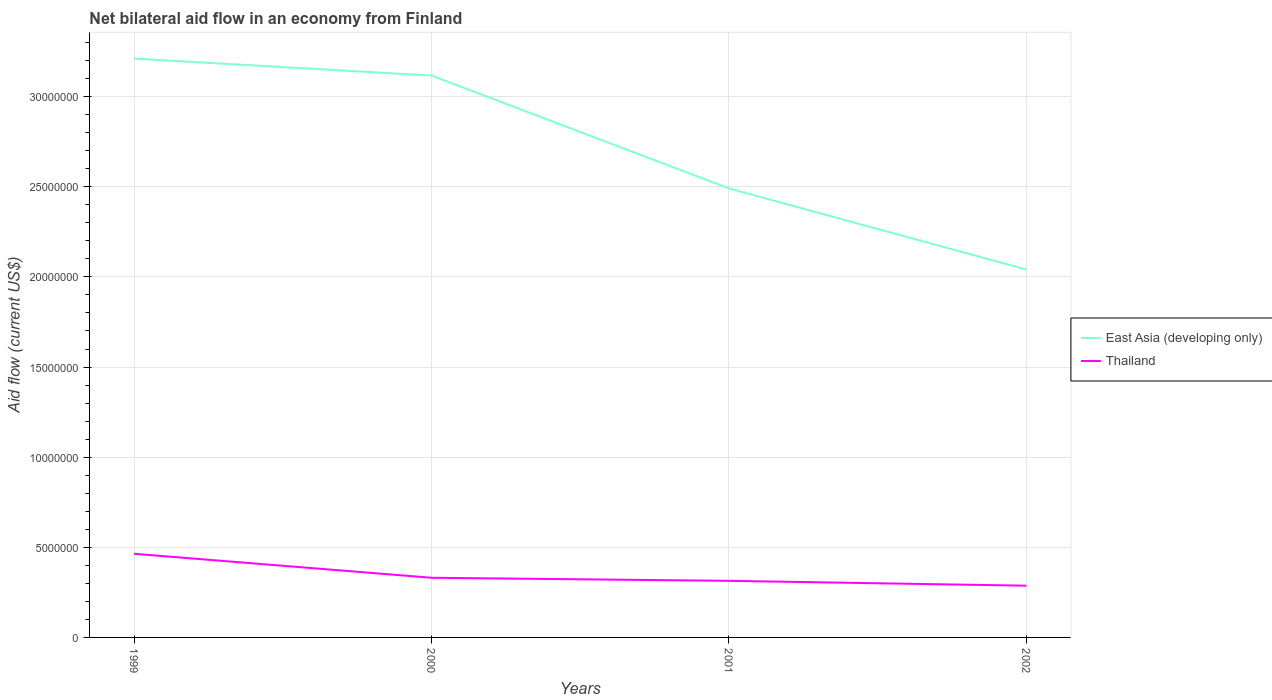How many different coloured lines are there?
Offer a terse response. 2. Across all years, what is the maximum net bilateral aid flow in Thailand?
Offer a very short reply. 2.87e+06. In which year was the net bilateral aid flow in East Asia (developing only) maximum?
Offer a terse response. 2002. What is the total net bilateral aid flow in Thailand in the graph?
Give a very brief answer. 4.40e+05. What is the difference between the highest and the second highest net bilateral aid flow in East Asia (developing only)?
Your response must be concise. 1.17e+07. What is the difference between the highest and the lowest net bilateral aid flow in East Asia (developing only)?
Offer a very short reply. 2. How many lines are there?
Provide a short and direct response. 2. Are the values on the major ticks of Y-axis written in scientific E-notation?
Provide a short and direct response. No. How many legend labels are there?
Provide a succinct answer. 2. What is the title of the graph?
Your response must be concise. Net bilateral aid flow in an economy from Finland. Does "St. Vincent and the Grenadines" appear as one of the legend labels in the graph?
Make the answer very short. No. What is the label or title of the Y-axis?
Provide a succinct answer. Aid flow (current US$). What is the Aid flow (current US$) of East Asia (developing only) in 1999?
Offer a very short reply. 3.21e+07. What is the Aid flow (current US$) in Thailand in 1999?
Offer a very short reply. 4.64e+06. What is the Aid flow (current US$) in East Asia (developing only) in 2000?
Your answer should be compact. 3.12e+07. What is the Aid flow (current US$) of Thailand in 2000?
Offer a terse response. 3.31e+06. What is the Aid flow (current US$) in East Asia (developing only) in 2001?
Provide a short and direct response. 2.49e+07. What is the Aid flow (current US$) of Thailand in 2001?
Provide a succinct answer. 3.14e+06. What is the Aid flow (current US$) in East Asia (developing only) in 2002?
Offer a terse response. 2.04e+07. What is the Aid flow (current US$) in Thailand in 2002?
Make the answer very short. 2.87e+06. Across all years, what is the maximum Aid flow (current US$) of East Asia (developing only)?
Give a very brief answer. 3.21e+07. Across all years, what is the maximum Aid flow (current US$) in Thailand?
Make the answer very short. 4.64e+06. Across all years, what is the minimum Aid flow (current US$) of East Asia (developing only)?
Provide a short and direct response. 2.04e+07. Across all years, what is the minimum Aid flow (current US$) of Thailand?
Provide a succinct answer. 2.87e+06. What is the total Aid flow (current US$) of East Asia (developing only) in the graph?
Offer a terse response. 1.09e+08. What is the total Aid flow (current US$) in Thailand in the graph?
Provide a short and direct response. 1.40e+07. What is the difference between the Aid flow (current US$) of East Asia (developing only) in 1999 and that in 2000?
Keep it short and to the point. 9.40e+05. What is the difference between the Aid flow (current US$) of Thailand in 1999 and that in 2000?
Make the answer very short. 1.33e+06. What is the difference between the Aid flow (current US$) in East Asia (developing only) in 1999 and that in 2001?
Offer a terse response. 7.20e+06. What is the difference between the Aid flow (current US$) in Thailand in 1999 and that in 2001?
Keep it short and to the point. 1.50e+06. What is the difference between the Aid flow (current US$) in East Asia (developing only) in 1999 and that in 2002?
Make the answer very short. 1.17e+07. What is the difference between the Aid flow (current US$) of Thailand in 1999 and that in 2002?
Your response must be concise. 1.77e+06. What is the difference between the Aid flow (current US$) of East Asia (developing only) in 2000 and that in 2001?
Your response must be concise. 6.26e+06. What is the difference between the Aid flow (current US$) in Thailand in 2000 and that in 2001?
Ensure brevity in your answer.  1.70e+05. What is the difference between the Aid flow (current US$) of East Asia (developing only) in 2000 and that in 2002?
Your answer should be compact. 1.08e+07. What is the difference between the Aid flow (current US$) of East Asia (developing only) in 2001 and that in 2002?
Keep it short and to the point. 4.50e+06. What is the difference between the Aid flow (current US$) in East Asia (developing only) in 1999 and the Aid flow (current US$) in Thailand in 2000?
Provide a succinct answer. 2.88e+07. What is the difference between the Aid flow (current US$) of East Asia (developing only) in 1999 and the Aid flow (current US$) of Thailand in 2001?
Your answer should be very brief. 2.90e+07. What is the difference between the Aid flow (current US$) of East Asia (developing only) in 1999 and the Aid flow (current US$) of Thailand in 2002?
Your response must be concise. 2.92e+07. What is the difference between the Aid flow (current US$) in East Asia (developing only) in 2000 and the Aid flow (current US$) in Thailand in 2001?
Provide a short and direct response. 2.80e+07. What is the difference between the Aid flow (current US$) in East Asia (developing only) in 2000 and the Aid flow (current US$) in Thailand in 2002?
Your answer should be compact. 2.83e+07. What is the difference between the Aid flow (current US$) in East Asia (developing only) in 2001 and the Aid flow (current US$) in Thailand in 2002?
Offer a terse response. 2.20e+07. What is the average Aid flow (current US$) in East Asia (developing only) per year?
Offer a terse response. 2.72e+07. What is the average Aid flow (current US$) in Thailand per year?
Provide a short and direct response. 3.49e+06. In the year 1999, what is the difference between the Aid flow (current US$) of East Asia (developing only) and Aid flow (current US$) of Thailand?
Offer a very short reply. 2.75e+07. In the year 2000, what is the difference between the Aid flow (current US$) of East Asia (developing only) and Aid flow (current US$) of Thailand?
Give a very brief answer. 2.79e+07. In the year 2001, what is the difference between the Aid flow (current US$) of East Asia (developing only) and Aid flow (current US$) of Thailand?
Offer a very short reply. 2.18e+07. In the year 2002, what is the difference between the Aid flow (current US$) of East Asia (developing only) and Aid flow (current US$) of Thailand?
Give a very brief answer. 1.75e+07. What is the ratio of the Aid flow (current US$) in East Asia (developing only) in 1999 to that in 2000?
Your answer should be very brief. 1.03. What is the ratio of the Aid flow (current US$) of Thailand in 1999 to that in 2000?
Your response must be concise. 1.4. What is the ratio of the Aid flow (current US$) in East Asia (developing only) in 1999 to that in 2001?
Keep it short and to the point. 1.29. What is the ratio of the Aid flow (current US$) in Thailand in 1999 to that in 2001?
Ensure brevity in your answer.  1.48. What is the ratio of the Aid flow (current US$) of East Asia (developing only) in 1999 to that in 2002?
Your answer should be compact. 1.57. What is the ratio of the Aid flow (current US$) in Thailand in 1999 to that in 2002?
Offer a terse response. 1.62. What is the ratio of the Aid flow (current US$) of East Asia (developing only) in 2000 to that in 2001?
Your answer should be very brief. 1.25. What is the ratio of the Aid flow (current US$) in Thailand in 2000 to that in 2001?
Your answer should be compact. 1.05. What is the ratio of the Aid flow (current US$) in East Asia (developing only) in 2000 to that in 2002?
Your answer should be very brief. 1.53. What is the ratio of the Aid flow (current US$) in Thailand in 2000 to that in 2002?
Offer a very short reply. 1.15. What is the ratio of the Aid flow (current US$) of East Asia (developing only) in 2001 to that in 2002?
Provide a short and direct response. 1.22. What is the ratio of the Aid flow (current US$) of Thailand in 2001 to that in 2002?
Ensure brevity in your answer.  1.09. What is the difference between the highest and the second highest Aid flow (current US$) in East Asia (developing only)?
Give a very brief answer. 9.40e+05. What is the difference between the highest and the second highest Aid flow (current US$) of Thailand?
Ensure brevity in your answer.  1.33e+06. What is the difference between the highest and the lowest Aid flow (current US$) in East Asia (developing only)?
Your answer should be compact. 1.17e+07. What is the difference between the highest and the lowest Aid flow (current US$) of Thailand?
Your response must be concise. 1.77e+06. 